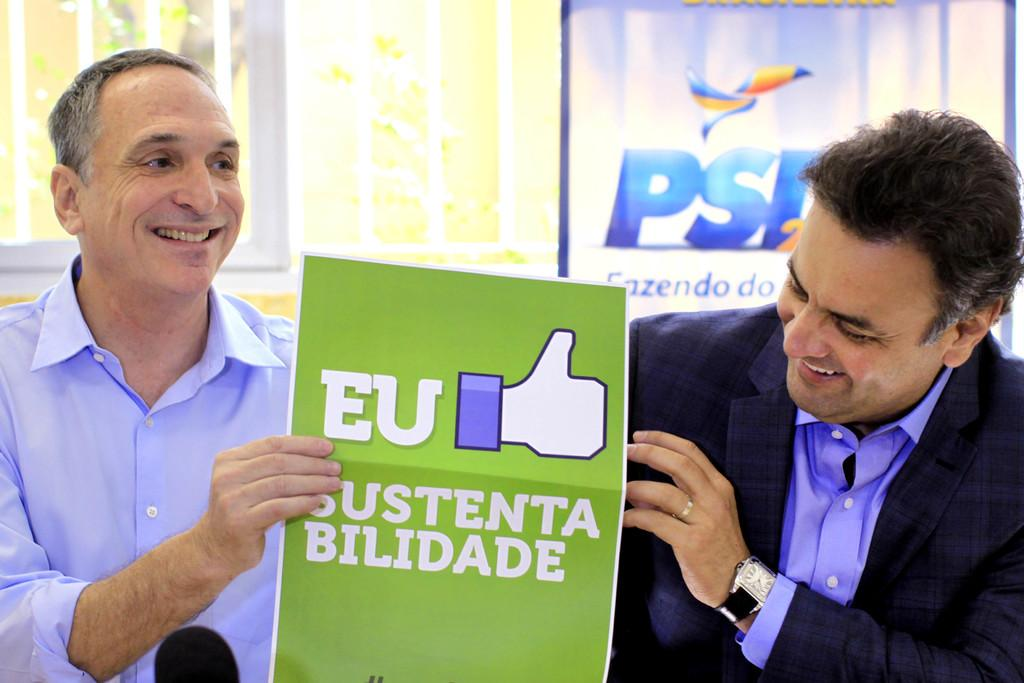How many people are in the image? There are two persons in the image. What are the persons doing in the image? The persons are smiling and holding a poster. What can be seen in the background of the image? There are iron grilles and a board in the background of the image. What type of boats can be seen sailing in the background of the image? There are no boats visible in the image; it features two persons holding a poster with iron grilles and a board in the background. What kind of ink is used to write on the board in the image? There is no writing or ink present on the board in the image. 